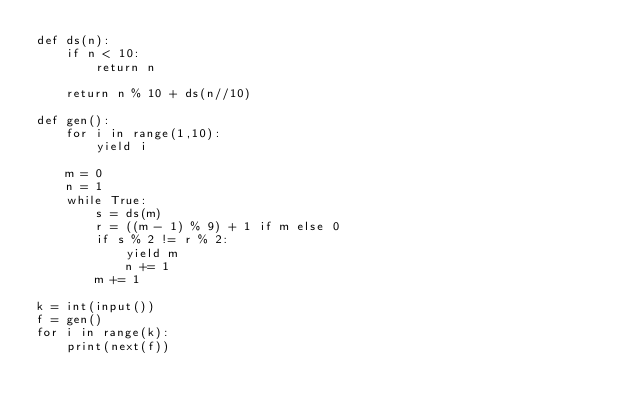Convert code to text. <code><loc_0><loc_0><loc_500><loc_500><_Python_>def ds(n):
    if n < 10:
        return n

    return n % 10 + ds(n//10)

def gen():
    for i in range(1,10):
        yield i
        
    m = 0
    n = 1
    while True:
        s = ds(m)
        r = ((m - 1) % 9) + 1 if m else 0
        if s % 2 != r % 2:
            yield m
            n += 1
        m += 1

k = int(input())
f = gen()
for i in range(k):
    print(next(f))</code> 